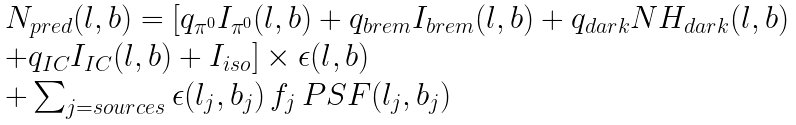Convert formula to latex. <formula><loc_0><loc_0><loc_500><loc_500>\begin{array} { l } N _ { p r e d } ( l , b ) = [ q _ { \pi ^ { 0 } } I _ { \pi ^ { 0 } } ( l , b ) + q _ { b r e m } I _ { b r e m } ( l , b ) + q _ { d a r k } N H _ { d a r k } ( l , b ) \\ + q _ { I C } I _ { I C } ( l , b ) + I _ { i s o } ] \times \epsilon ( l , b ) \\ + \sum _ { j = s o u r c e s } \epsilon ( l _ { j } , b _ { j } ) \, f _ { j } \, P S F ( l _ { j } , b _ { j } ) \end{array}</formula> 